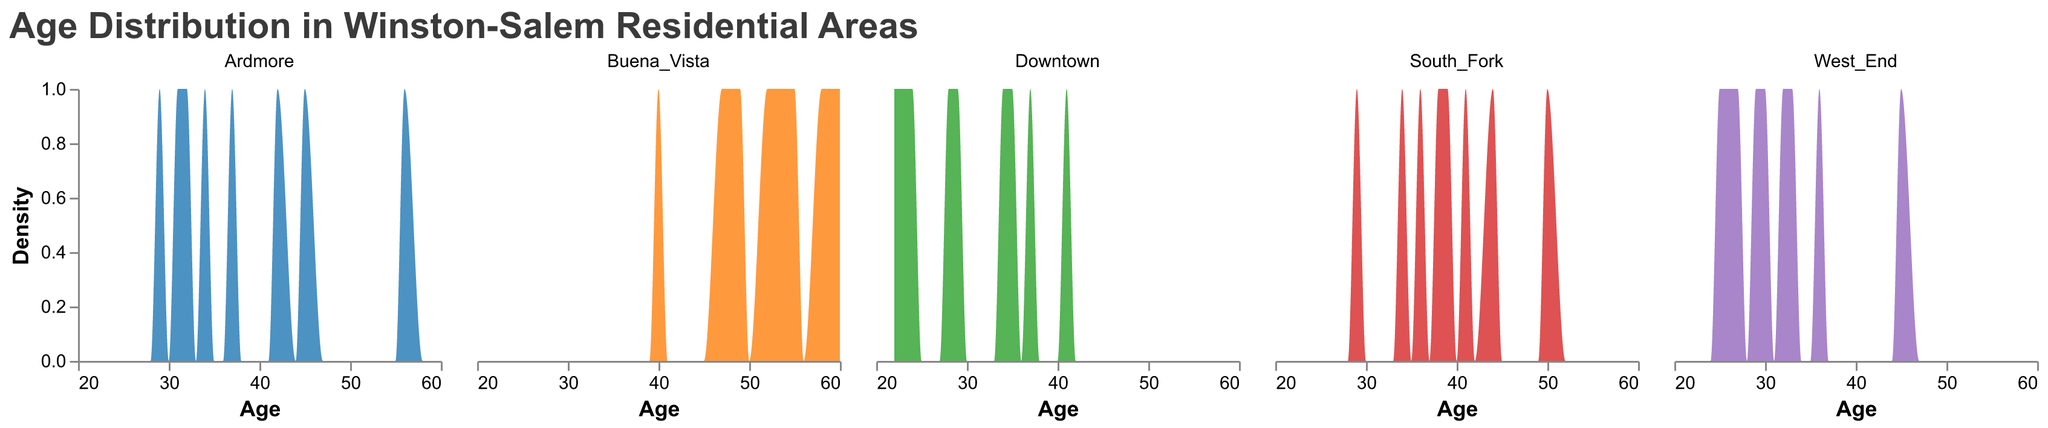What is the title of the figure? The title is typically displayed at the top of the figure. Here, the title "Age Distribution in Winston-Salem Residential Areas" is clearly indicated.
Answer: Age Distribution in Winston-Salem Residential Areas Which residential area appears to have the widest age distribution? By inspecting the spread of the age values on the x-axis, we can observe that Buena_Vista has the widest age distribution ranging from 40 to 60.
Answer: Buena_Vista In which residential area do we see the count of residents peaking around age 29? Inspection of the density peaks near age 29 will show that both Downtown and Ardmore have peaks around age 29.
Answer: Downtown and Ardmore Which areas show a concentration of younger age groups (ages in the 20s)? By looking at the areas with peaks in the age distribution in the 20s, it is clear that Downtown and West_End both show peaks in this age range.
Answer: Downtown and West_End How does the age distribution in Ardmore compare to that in Buena_Vista in terms of concentration of older residents (ages above 50)? Buena_Vista has a higher concentration of older residents as seen from the density peaks above age 50, compared to Ardmore which has fewer peaks in that age range.
Answer: Buena_Vista has more older residents What is the common age range for residents in South_Fork? Reviewing the density plot for South_Fork shows that most of the residents fall within the age range of 29 to 50.
Answer: 29 to 50 Which residential area has no residents in their twenties according to the plot? From the density plots, it is observable that all areas except Buena_Vista have residents in their twenties; Buena_Vista starts around age 40.
Answer: Buena_Vista Are there any residential areas with similar age distributions? By comparing the shapes and peaks of density plots, we can see that Downtown and West_End have similar distributions with younger age concentrations, while South_Fork and Ardmore show more middle-aged concentrations.
Answer: Downtown and West_End or South_Fork and Ardmore Which residential area shows the least variation in age distribution? By observing the compactness of the density plot, West_End has a narrower and more peaked distribution of ages, indicating less variation.
Answer: West_End 